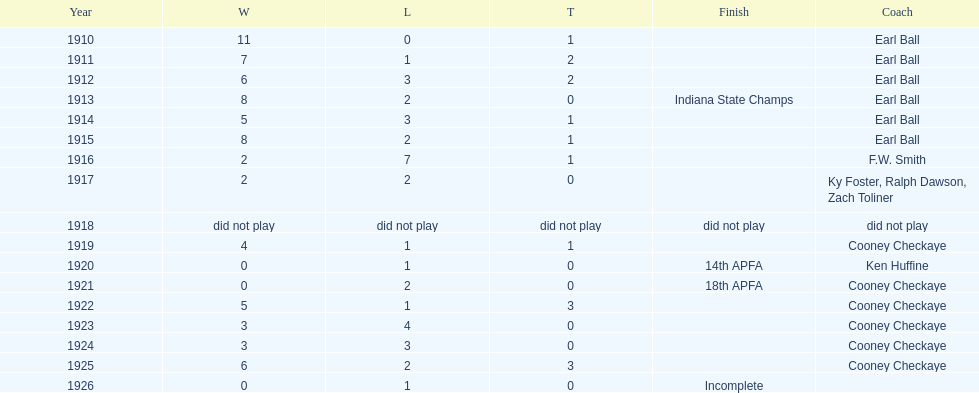Can you give me this table as a dict? {'header': ['Year', 'W', 'L', 'T', 'Finish', 'Coach'], 'rows': [['1910', '11', '0', '1', '', 'Earl Ball'], ['1911', '7', '1', '2', '', 'Earl Ball'], ['1912', '6', '3', '2', '', 'Earl Ball'], ['1913', '8', '2', '0', 'Indiana State Champs', 'Earl Ball'], ['1914', '5', '3', '1', '', 'Earl Ball'], ['1915', '8', '2', '1', '', 'Earl Ball'], ['1916', '2', '7', '1', '', 'F.W. Smith'], ['1917', '2', '2', '0', '', 'Ky Foster, Ralph Dawson, Zach Toliner'], ['1918', 'did not play', 'did not play', 'did not play', 'did not play', 'did not play'], ['1919', '4', '1', '1', '', 'Cooney Checkaye'], ['1920', '0', '1', '0', '14th APFA', 'Ken Huffine'], ['1921', '0', '2', '0', '18th APFA', 'Cooney Checkaye'], ['1922', '5', '1', '3', '', 'Cooney Checkaye'], ['1923', '3', '4', '0', '', 'Cooney Checkaye'], ['1924', '3', '3', '0', '', 'Cooney Checkaye'], ['1925', '6', '2', '3', '', 'Cooney Checkaye'], ['1926', '0', '1', '0', 'Incomplete', '']]} The muncie flyers participated from 1910 to 1925, except for one year. in which year did the flyers not compete? 1918. 